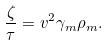<formula> <loc_0><loc_0><loc_500><loc_500>\frac { \zeta } { \tau } = v ^ { 2 } \gamma _ { m } \rho _ { m } .</formula> 